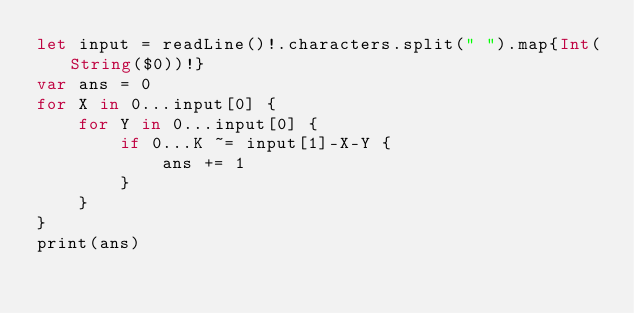Convert code to text. <code><loc_0><loc_0><loc_500><loc_500><_Swift_>let input = readLine()!.characters.split(" ").map{Int(String($0))!}
var ans = 0
for X in 0...input[0] {
    for Y in 0...input[0] {
        if 0...K ~= input[1]-X-Y {
            ans += 1
        }
    }
}
print(ans)</code> 